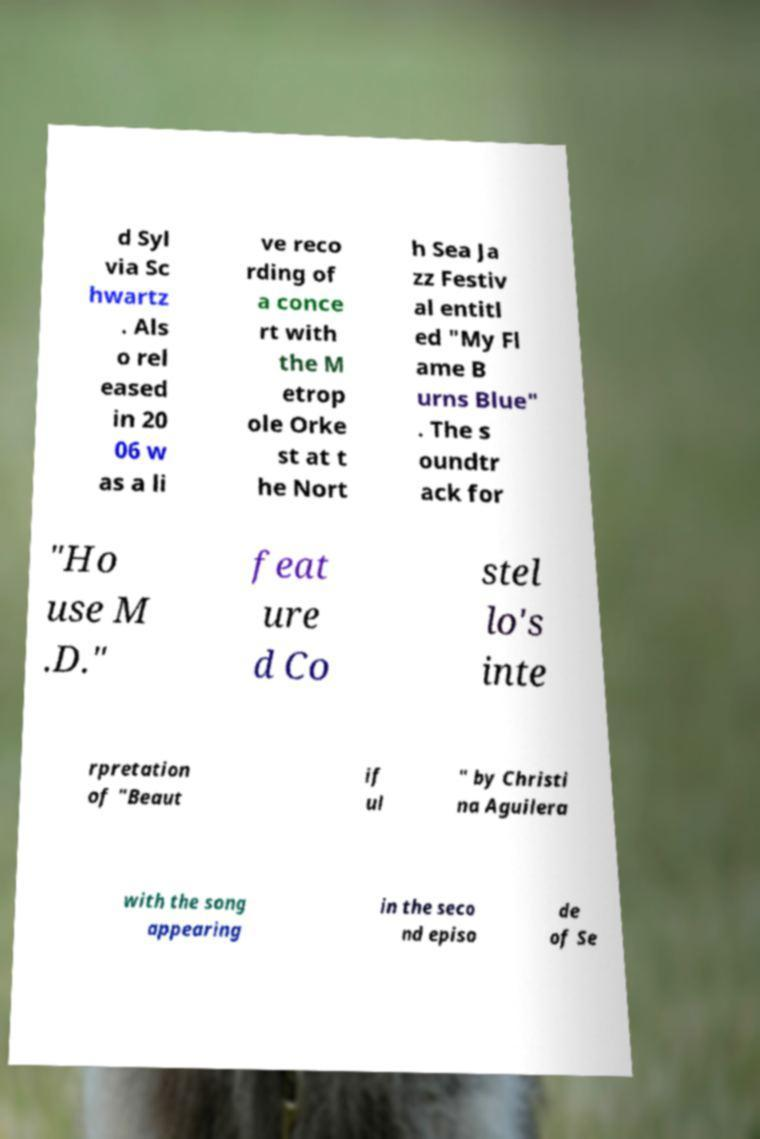Please read and relay the text visible in this image. What does it say? d Syl via Sc hwartz . Als o rel eased in 20 06 w as a li ve reco rding of a conce rt with the M etrop ole Orke st at t he Nort h Sea Ja zz Festiv al entitl ed "My Fl ame B urns Blue" . The s oundtr ack for "Ho use M .D." feat ure d Co stel lo's inte rpretation of "Beaut if ul " by Christi na Aguilera with the song appearing in the seco nd episo de of Se 